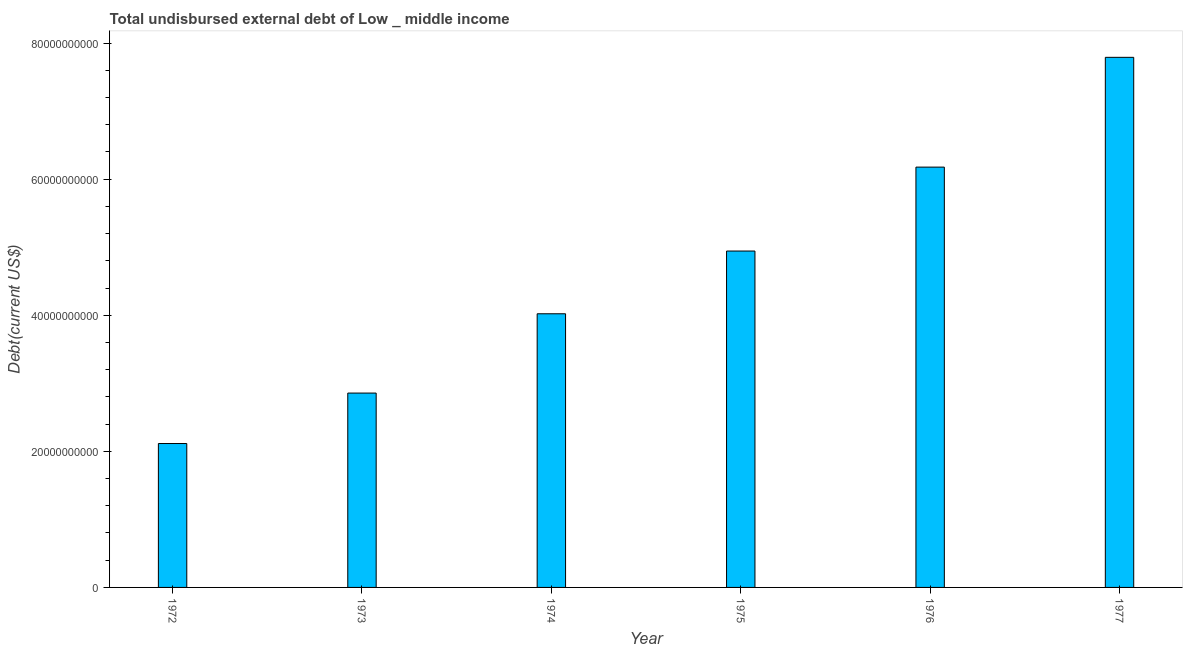Does the graph contain grids?
Ensure brevity in your answer.  No. What is the title of the graph?
Your answer should be very brief. Total undisbursed external debt of Low _ middle income. What is the label or title of the Y-axis?
Provide a succinct answer. Debt(current US$). What is the total debt in 1975?
Offer a very short reply. 4.94e+1. Across all years, what is the maximum total debt?
Offer a very short reply. 7.79e+1. Across all years, what is the minimum total debt?
Your answer should be very brief. 2.11e+1. In which year was the total debt maximum?
Keep it short and to the point. 1977. In which year was the total debt minimum?
Give a very brief answer. 1972. What is the sum of the total debt?
Keep it short and to the point. 2.79e+11. What is the difference between the total debt in 1974 and 1977?
Ensure brevity in your answer.  -3.77e+1. What is the average total debt per year?
Your response must be concise. 4.65e+1. What is the median total debt?
Offer a very short reply. 4.48e+1. In how many years, is the total debt greater than 16000000000 US$?
Make the answer very short. 6. What is the ratio of the total debt in 1972 to that in 1975?
Make the answer very short. 0.43. Is the total debt in 1972 less than that in 1973?
Ensure brevity in your answer.  Yes. Is the difference between the total debt in 1975 and 1977 greater than the difference between any two years?
Your answer should be very brief. No. What is the difference between the highest and the second highest total debt?
Give a very brief answer. 1.61e+1. What is the difference between the highest and the lowest total debt?
Provide a succinct answer. 5.68e+1. How many bars are there?
Keep it short and to the point. 6. Are all the bars in the graph horizontal?
Give a very brief answer. No. What is the difference between two consecutive major ticks on the Y-axis?
Make the answer very short. 2.00e+1. What is the Debt(current US$) of 1972?
Provide a succinct answer. 2.11e+1. What is the Debt(current US$) in 1973?
Provide a succinct answer. 2.86e+1. What is the Debt(current US$) of 1974?
Keep it short and to the point. 4.02e+1. What is the Debt(current US$) of 1975?
Make the answer very short. 4.94e+1. What is the Debt(current US$) in 1976?
Your response must be concise. 6.18e+1. What is the Debt(current US$) of 1977?
Offer a very short reply. 7.79e+1. What is the difference between the Debt(current US$) in 1972 and 1973?
Offer a terse response. -7.42e+09. What is the difference between the Debt(current US$) in 1972 and 1974?
Provide a succinct answer. -1.91e+1. What is the difference between the Debt(current US$) in 1972 and 1975?
Make the answer very short. -2.83e+1. What is the difference between the Debt(current US$) in 1972 and 1976?
Your answer should be very brief. -4.06e+1. What is the difference between the Debt(current US$) in 1972 and 1977?
Give a very brief answer. -5.68e+1. What is the difference between the Debt(current US$) in 1973 and 1974?
Give a very brief answer. -1.17e+1. What is the difference between the Debt(current US$) in 1973 and 1975?
Provide a succinct answer. -2.09e+1. What is the difference between the Debt(current US$) in 1973 and 1976?
Give a very brief answer. -3.32e+1. What is the difference between the Debt(current US$) in 1973 and 1977?
Offer a very short reply. -4.93e+1. What is the difference between the Debt(current US$) in 1974 and 1975?
Keep it short and to the point. -9.22e+09. What is the difference between the Debt(current US$) in 1974 and 1976?
Make the answer very short. -2.16e+1. What is the difference between the Debt(current US$) in 1974 and 1977?
Make the answer very short. -3.77e+1. What is the difference between the Debt(current US$) in 1975 and 1976?
Make the answer very short. -1.23e+1. What is the difference between the Debt(current US$) in 1975 and 1977?
Offer a terse response. -2.85e+1. What is the difference between the Debt(current US$) in 1976 and 1977?
Keep it short and to the point. -1.61e+1. What is the ratio of the Debt(current US$) in 1972 to that in 1973?
Your answer should be very brief. 0.74. What is the ratio of the Debt(current US$) in 1972 to that in 1974?
Your answer should be compact. 0.53. What is the ratio of the Debt(current US$) in 1972 to that in 1975?
Offer a very short reply. 0.43. What is the ratio of the Debt(current US$) in 1972 to that in 1976?
Provide a succinct answer. 0.34. What is the ratio of the Debt(current US$) in 1972 to that in 1977?
Your answer should be compact. 0.27. What is the ratio of the Debt(current US$) in 1973 to that in 1974?
Provide a short and direct response. 0.71. What is the ratio of the Debt(current US$) in 1973 to that in 1975?
Give a very brief answer. 0.58. What is the ratio of the Debt(current US$) in 1973 to that in 1976?
Your response must be concise. 0.46. What is the ratio of the Debt(current US$) in 1973 to that in 1977?
Your response must be concise. 0.37. What is the ratio of the Debt(current US$) in 1974 to that in 1975?
Keep it short and to the point. 0.81. What is the ratio of the Debt(current US$) in 1974 to that in 1976?
Ensure brevity in your answer.  0.65. What is the ratio of the Debt(current US$) in 1974 to that in 1977?
Your answer should be very brief. 0.52. What is the ratio of the Debt(current US$) in 1975 to that in 1976?
Offer a terse response. 0.8. What is the ratio of the Debt(current US$) in 1975 to that in 1977?
Keep it short and to the point. 0.64. What is the ratio of the Debt(current US$) in 1976 to that in 1977?
Give a very brief answer. 0.79. 